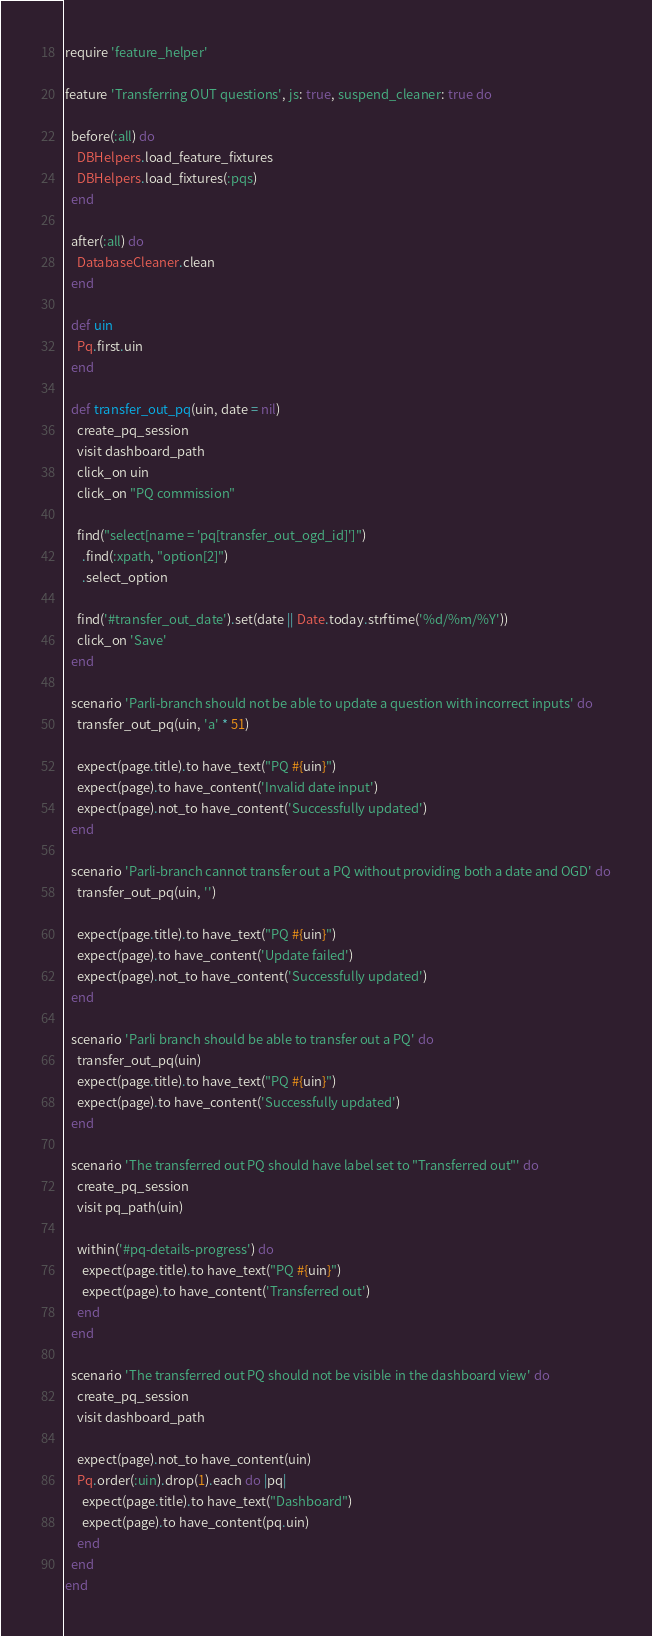Convert code to text. <code><loc_0><loc_0><loc_500><loc_500><_Ruby_>require 'feature_helper'

feature 'Transferring OUT questions', js: true, suspend_cleaner: true do

  before(:all) do
    DBHelpers.load_feature_fixtures
    DBHelpers.load_fixtures(:pqs)
  end

  after(:all) do
    DatabaseCleaner.clean
  end

  def uin
    Pq.first.uin
  end

  def transfer_out_pq(uin, date = nil)
    create_pq_session
    visit dashboard_path
    click_on uin
    click_on "PQ commission"

    find("select[name = 'pq[transfer_out_ogd_id]']")
      .find(:xpath, "option[2]")
      .select_option

    find('#transfer_out_date').set(date || Date.today.strftime('%d/%m/%Y'))
    click_on 'Save'
  end

  scenario 'Parli-branch should not be able to update a question with incorrect inputs' do
    transfer_out_pq(uin, 'a' * 51)

    expect(page.title).to have_text("PQ #{uin}")
    expect(page).to have_content('Invalid date input')
    expect(page).not_to have_content('Successfully updated')
  end

  scenario 'Parli-branch cannot transfer out a PQ without providing both a date and OGD' do
    transfer_out_pq(uin, '')

    expect(page.title).to have_text("PQ #{uin}")
    expect(page).to have_content('Update failed')
    expect(page).not_to have_content('Successfully updated')
  end

  scenario 'Parli branch should be able to transfer out a PQ' do
    transfer_out_pq(uin)
    expect(page.title).to have_text("PQ #{uin}")
    expect(page).to have_content('Successfully updated')
  end

  scenario 'The transferred out PQ should have label set to "Transferred out"' do
    create_pq_session
    visit pq_path(uin)

    within('#pq-details-progress') do
      expect(page.title).to have_text("PQ #{uin}")
      expect(page).to have_content('Transferred out')
    end
  end

  scenario 'The transferred out PQ should not be visible in the dashboard view' do
    create_pq_session
    visit dashboard_path

    expect(page).not_to have_content(uin)
    Pq.order(:uin).drop(1).each do |pq|
      expect(page.title).to have_text("Dashboard")
      expect(page).to have_content(pq.uin)
    end
  end
end
</code> 